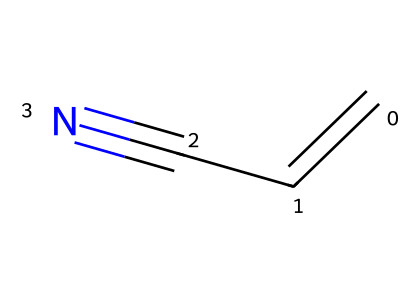What is the name of this chemical? The SMILES representation "C=CC#N" corresponds to a compound with a carbon-carbon double bond (C=C) and a carbon-nitrogen triple bond (C#N), which is characteristic of nitriles. The common name of this compound is acrylonitrile.
Answer: acrylonitrile How many carbon atoms are present in this molecule? By analyzing the SMILES structure, there are three 'C' characters indicating three carbon atoms in the compound.
Answer: 3 What type of functional group is present in this compound? The structure contains a carbon-nitrogen triple bond (C#N), which is a defining characteristic of nitriles. Hence, the functional group is a nitrile group.
Answer: nitrile What is the hybridization of the carbon atoms in the C=C double bond? In a double bond, one carbon is sp2 hybridized and the other carbon it is bonded to is also sp2 hybridized due to the presence of a double bond, allowing for planar structure around those carbon atoms.
Answer: sp2 How many hydrogen atoms are connected to the carbon atoms? Based on the structure, the terminal carbon bonded to the nitrogen has two hydrogen atoms, while the middle carbon has one hydrogen atom. Hence, the total number of hydrogen atoms is three.
Answer: 3 Which bond type is responsible for the compound's ability to form polymers? The carbon-carbon double bond (C=C) in acrylonitrile can undergo polymerization due to its reactivity, allowing it to form long-chain polymeric structures.
Answer: C=C Can this molecule participate in hydrogen bonding? Acrylonitrile, having a nitrile group (C#N), may not participate in strong hydrogen bonding like alcohols but can form weaker interactions due to the polarized C#N bond.
Answer: No 